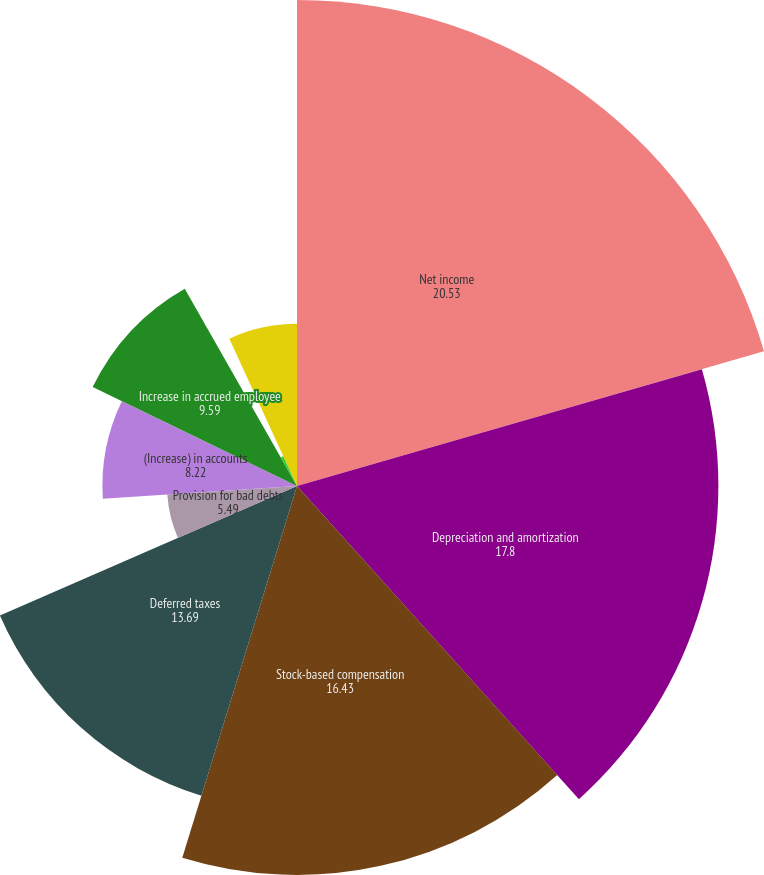Convert chart. <chart><loc_0><loc_0><loc_500><loc_500><pie_chart><fcel>Net income<fcel>Depreciation and amortization<fcel>Stock-based compensation<fcel>Deferred taxes<fcel>Provision for bad debts<fcel>(Increase) in accounts<fcel>Decrease (increase) in prepaid<fcel>Increase in accrued employee<fcel>(Decrease) in deferred revenue<fcel>Increase (decrease) in<nl><fcel>20.53%<fcel>17.8%<fcel>16.43%<fcel>13.69%<fcel>5.49%<fcel>8.22%<fcel>0.01%<fcel>9.59%<fcel>1.38%<fcel>6.85%<nl></chart> 